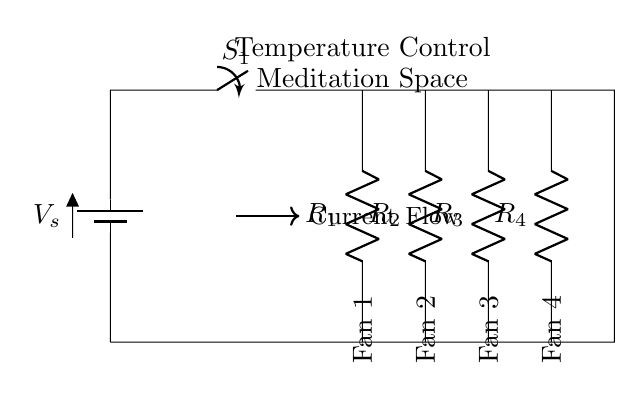What type of circuit is shown? The circuit diagram represents a parallel circuit, as the components (fans) are connected across the same voltage source, allowing for independent operation.
Answer: Parallel How many fans are connected? There are four fans connected to the circuit, as indicated by the four resistors labeled Fan 1, Fan 2, Fan 3, and Fan 4.
Answer: Four What is the purpose of the switch in the circuit? The switch can be used to control the flow of current to the fans; when it is closed, the fans operate, and when open, they do not.
Answer: Control What happens to the current if one fan fails? If one fan fails (one branch opens), the other fans continue to operate normally, since parallel circuits allow independent paths for the current flow.
Answer: Continue operating What does the notation "R" represent in the diagram? The notation "R" represents the resistors that are symbolically used to represent each fan's operational resistance in the circuit.
Answer: Resistors What is indicated by the arrow showing current flow? The arrow indicates the direction of current flow within the circuit, showing how the current moves from the power source to the fans.
Answer: Current direction 